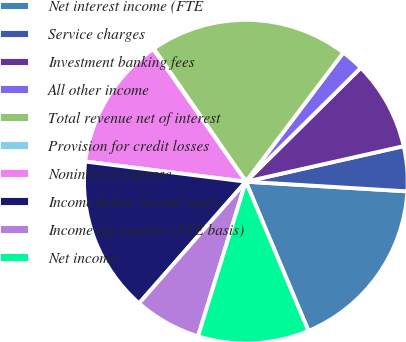Convert chart. <chart><loc_0><loc_0><loc_500><loc_500><pie_chart><fcel>Net interest income (FTE<fcel>Service charges<fcel>Investment banking fees<fcel>All other income<fcel>Total revenue net of interest<fcel>Provision for credit losses<fcel>Noninterest expense<fcel>Income before income taxes<fcel>Income tax expense (FTE basis)<fcel>Net income<nl><fcel>17.72%<fcel>4.48%<fcel>8.9%<fcel>2.28%<fcel>19.93%<fcel>0.07%<fcel>13.31%<fcel>15.52%<fcel>6.69%<fcel>11.1%<nl></chart> 